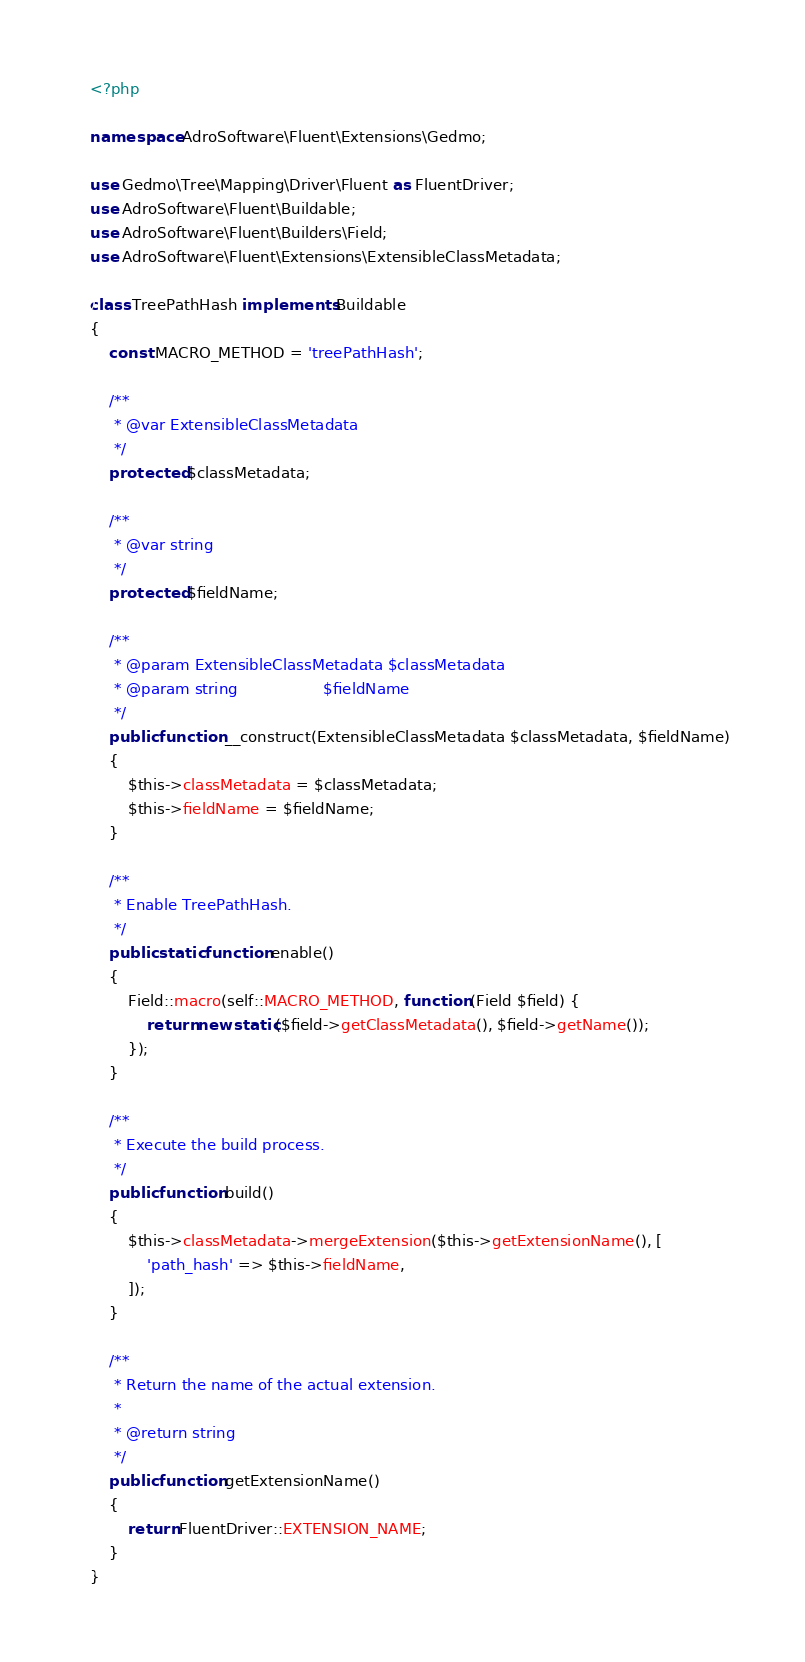Convert code to text. <code><loc_0><loc_0><loc_500><loc_500><_PHP_><?php

namespace AdroSoftware\Fluent\Extensions\Gedmo;

use Gedmo\Tree\Mapping\Driver\Fluent as FluentDriver;
use AdroSoftware\Fluent\Buildable;
use AdroSoftware\Fluent\Builders\Field;
use AdroSoftware\Fluent\Extensions\ExtensibleClassMetadata;

class TreePathHash implements Buildable
{
    const MACRO_METHOD = 'treePathHash';

    /**
     * @var ExtensibleClassMetadata
     */
    protected $classMetadata;

    /**
     * @var string
     */
    protected $fieldName;

    /**
     * @param ExtensibleClassMetadata $classMetadata
     * @param string                  $fieldName
     */
    public function __construct(ExtensibleClassMetadata $classMetadata, $fieldName)
    {
        $this->classMetadata = $classMetadata;
        $this->fieldName = $fieldName;
    }

    /**
     * Enable TreePathHash.
     */
    public static function enable()
    {
        Field::macro(self::MACRO_METHOD, function (Field $field) {
            return new static($field->getClassMetadata(), $field->getName());
        });
    }

    /**
     * Execute the build process.
     */
    public function build()
    {
        $this->classMetadata->mergeExtension($this->getExtensionName(), [
            'path_hash' => $this->fieldName,
        ]);
    }

    /**
     * Return the name of the actual extension.
     *
     * @return string
     */
    public function getExtensionName()
    {
        return FluentDriver::EXTENSION_NAME;
    }
}
</code> 